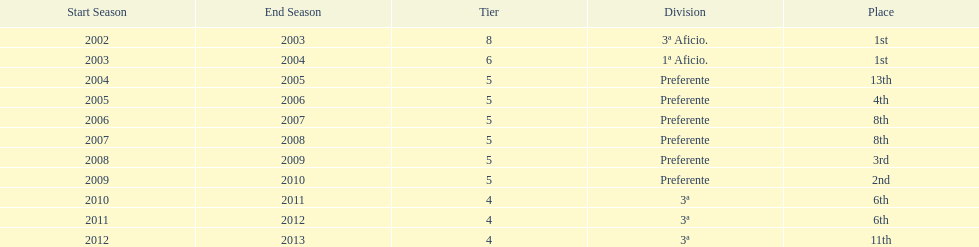How many seasons did internacional de madrid cf play in the preferente division? 6. 